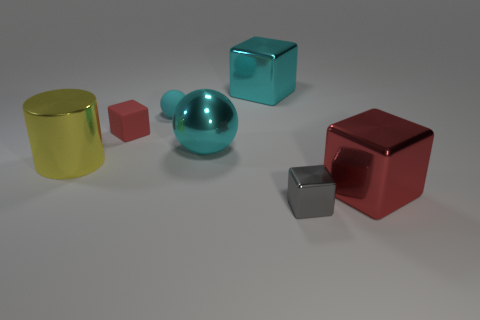Subtract 1 blocks. How many blocks are left? 3 Subtract all green blocks. Subtract all cyan spheres. How many blocks are left? 4 Add 1 large yellow cylinders. How many objects exist? 8 Subtract all blocks. How many objects are left? 3 Subtract all cyan metallic balls. Subtract all red rubber things. How many objects are left? 5 Add 2 large yellow shiny cylinders. How many large yellow shiny cylinders are left? 3 Add 1 tiny red blocks. How many tiny red blocks exist? 2 Subtract 0 gray cylinders. How many objects are left? 7 